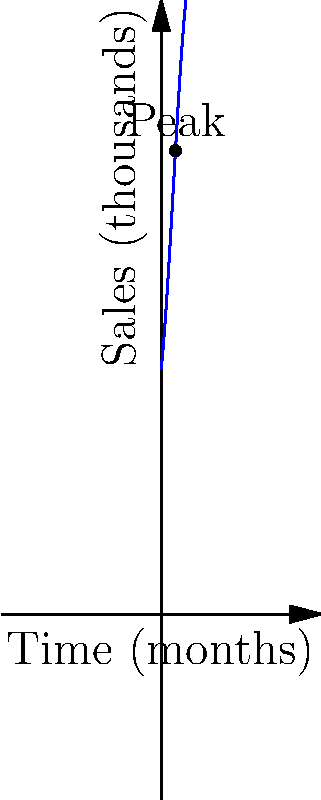You've just released your debut mixtape, and your record sales can be modeled by the polynomial function $S(t) = -0.1t^3 + 1.5t^2 + 10t + 100$, where $S$ represents sales in thousands and $t$ represents time in months since release. At how many months after the release will your sales peak? To find the peak of the sales, we need to follow these steps:

1) The peak occurs at the maximum point of the function, which is where the derivative equals zero.

2) Let's find the derivative of $S(t)$:
   $S'(t) = -0.3t^2 + 3t + 10$

3) Set the derivative equal to zero:
   $-0.3t^2 + 3t + 10 = 0$

4) This is a quadratic equation. We can solve it using the quadratic formula:
   $t = \frac{-b \pm \sqrt{b^2 - 4ac}}{2a}$

   Where $a = -0.3$, $b = 3$, and $c = 10$

5) Plugging in these values:
   $t = \frac{-3 \pm \sqrt{3^2 - 4(-0.3)(10)}}{2(-0.3)}$

6) Simplifying:
   $t = \frac{-3 \pm \sqrt{9 + 12}}{-0.6} = \frac{-3 \pm \sqrt{21}}{-0.6}$

7) This gives us two solutions:
   $t_1 \approx 5.8$ and $t_2 \approx -1.8$

8) Since time can't be negative in this context, we discard the negative solution.

Therefore, sales will peak approximately 5.8 months after the release.
Answer: 5.8 months 